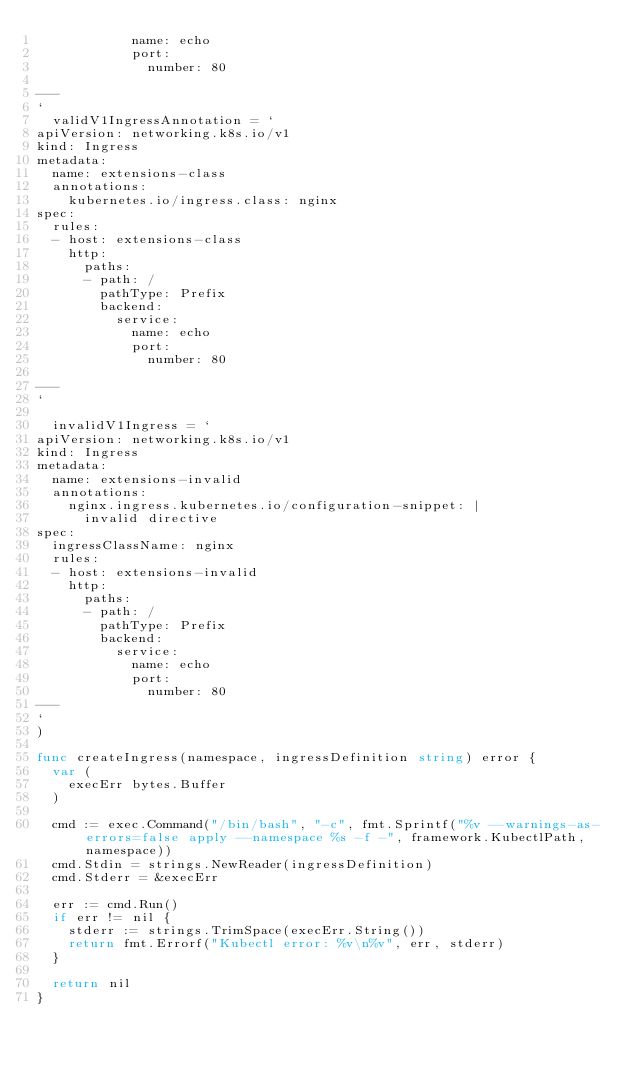Convert code to text. <code><loc_0><loc_0><loc_500><loc_500><_Go_>            name: echo
            port:
              number: 80

---
`
	validV1IngressAnnotation = `
apiVersion: networking.k8s.io/v1
kind: Ingress
metadata:
  name: extensions-class
  annotations:
    kubernetes.io/ingress.class: nginx
spec:
  rules:
  - host: extensions-class
    http:
      paths:
      - path: /
        pathType: Prefix
        backend:
          service:
            name: echo
            port:
              number: 80

---
`

	invalidV1Ingress = `
apiVersion: networking.k8s.io/v1
kind: Ingress
metadata:
  name: extensions-invalid
  annotations:
    nginx.ingress.kubernetes.io/configuration-snippet: |
      invalid directive
spec:
  ingressClassName: nginx
  rules:
  - host: extensions-invalid
    http:
      paths:
      - path: /
        pathType: Prefix
        backend:
          service:
            name: echo
            port:
              number: 80
---
`
)

func createIngress(namespace, ingressDefinition string) error {
	var (
		execErr bytes.Buffer
	)

	cmd := exec.Command("/bin/bash", "-c", fmt.Sprintf("%v --warnings-as-errors=false apply --namespace %s -f -", framework.KubectlPath, namespace))
	cmd.Stdin = strings.NewReader(ingressDefinition)
	cmd.Stderr = &execErr

	err := cmd.Run()
	if err != nil {
		stderr := strings.TrimSpace(execErr.String())
		return fmt.Errorf("Kubectl error: %v\n%v", err, stderr)
	}

	return nil
}
</code> 